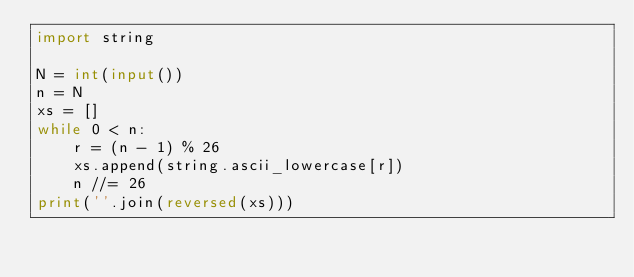Convert code to text. <code><loc_0><loc_0><loc_500><loc_500><_Python_>import string

N = int(input())
n = N
xs = []
while 0 < n:
    r = (n - 1) % 26
    xs.append(string.ascii_lowercase[r])
    n //= 26
print(''.join(reversed(xs)))</code> 